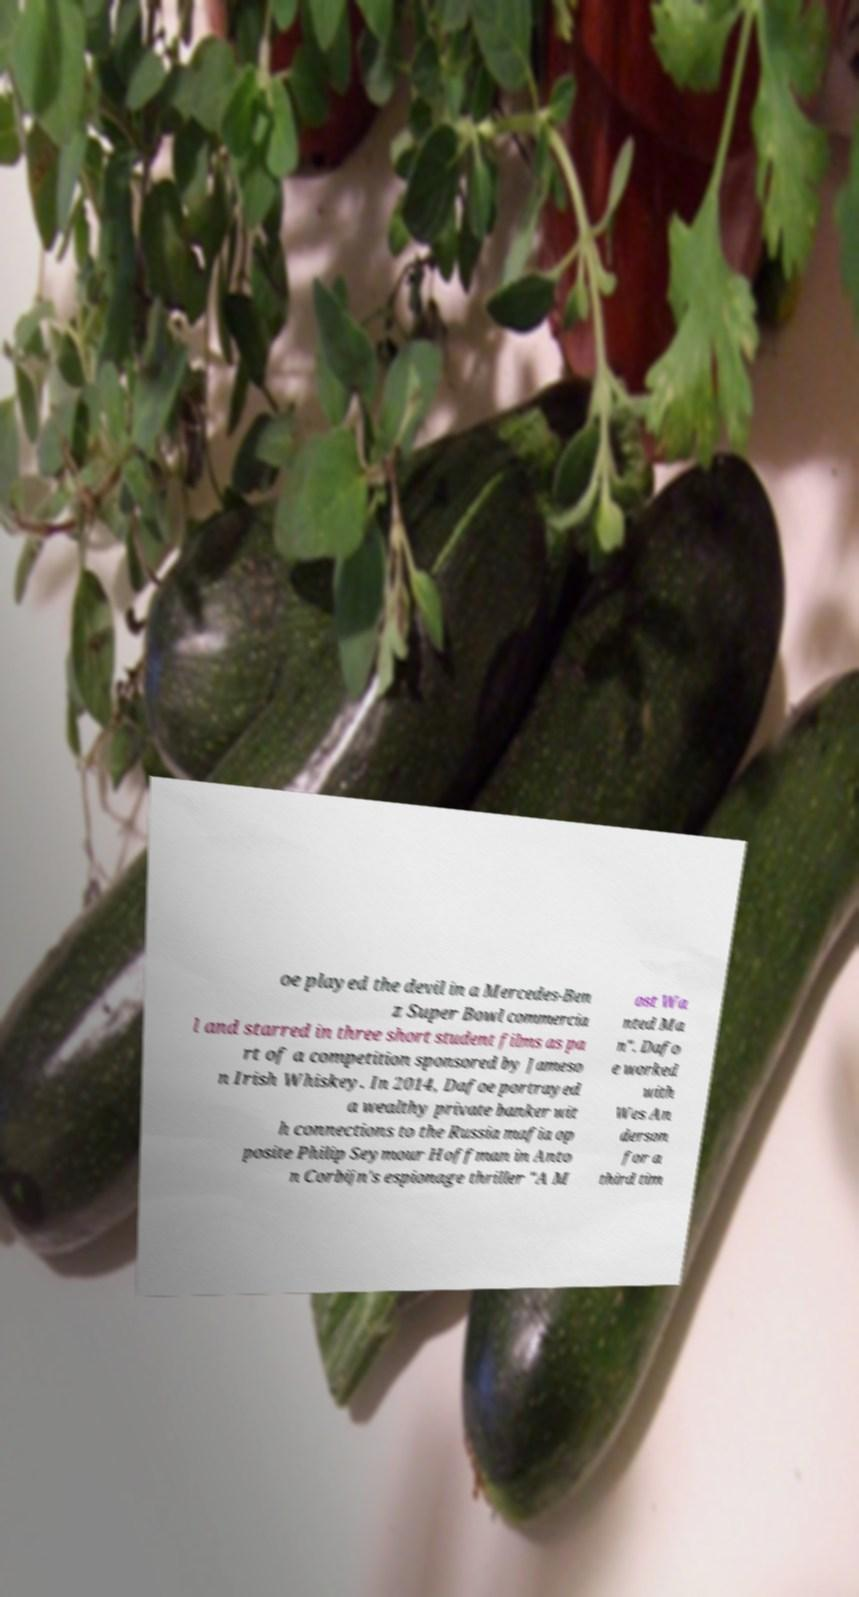Please identify and transcribe the text found in this image. oe played the devil in a Mercedes-Ben z Super Bowl commercia l and starred in three short student films as pa rt of a competition sponsored by Jameso n Irish Whiskey. In 2014, Dafoe portrayed a wealthy private banker wit h connections to the Russia mafia op posite Philip Seymour Hoffman in Anto n Corbijn's espionage thriller "A M ost Wa nted Ma n". Dafo e worked with Wes An derson for a third tim 